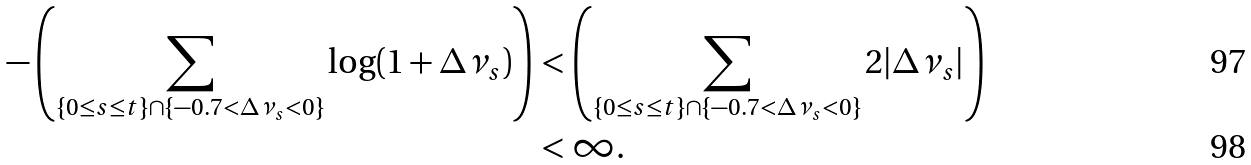Convert formula to latex. <formula><loc_0><loc_0><loc_500><loc_500>- \left ( \sum _ { \{ 0 \leq s \leq t \} \cap \{ - 0 . 7 < \Delta \nu _ { s } < 0 \} } \log ( 1 + \Delta \nu _ { s } ) \right ) & < \left ( \sum _ { \{ 0 \leq s \leq t \} \cap \{ - 0 . 7 < \Delta \nu _ { s } < 0 \} } 2 | \Delta \nu _ { s } | \right ) \\ & < \infty .</formula> 